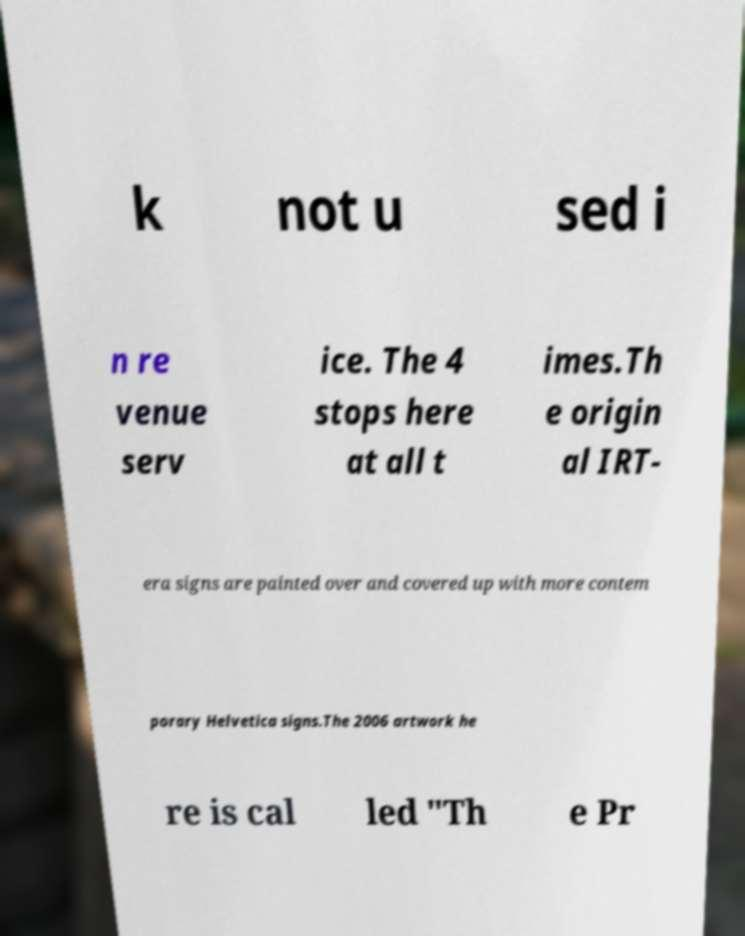For documentation purposes, I need the text within this image transcribed. Could you provide that? k not u sed i n re venue serv ice. The 4 stops here at all t imes.Th e origin al IRT- era signs are painted over and covered up with more contem porary Helvetica signs.The 2006 artwork he re is cal led "Th e Pr 